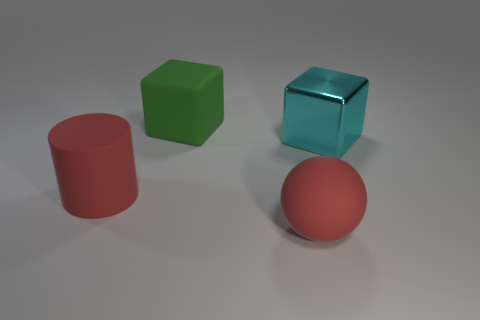Subtract all gray cylinders. Subtract all brown blocks. How many cylinders are left? 1 Add 4 matte spheres. How many objects exist? 8 Subtract all cylinders. How many objects are left? 3 Subtract all large red cylinders. Subtract all large red things. How many objects are left? 1 Add 1 big rubber cubes. How many big rubber cubes are left? 2 Add 4 brown cylinders. How many brown cylinders exist? 4 Subtract 0 yellow cubes. How many objects are left? 4 